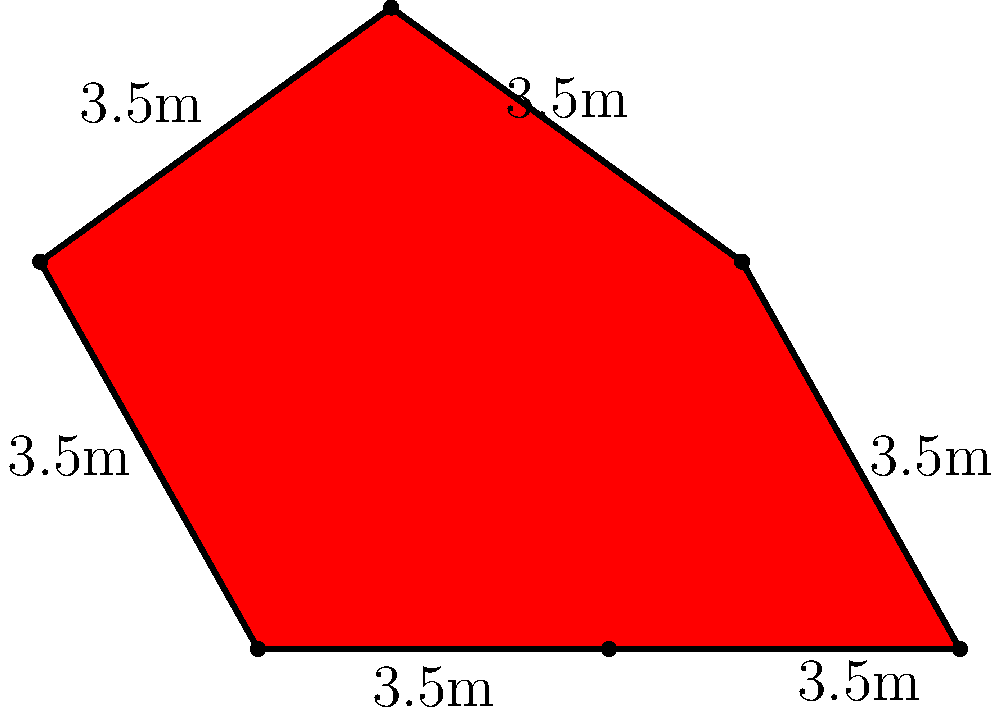For the upcoming premiere of a highly anticipated Romanian film, you've been tasked with reporting on the unique star-shaped red carpet. The carpet has 6 equal sides, each measuring 3.5 meters. What is the perimeter of this eye-catching red carpet that will be graced by local celebrities? To find the perimeter of the star-shaped red carpet, we need to follow these steps:

1. Identify the shape: The carpet is a 6-pointed star with equal sides.

2. Understand the given information:
   - Each side of the star measures 3.5 meters.
   - There are 6 sides in total.

3. Calculate the perimeter:
   - The perimeter is the sum of all sides.
   - Since all sides are equal, we can multiply the length of one side by the number of sides.
   - Perimeter = $6 \times 3.5$ meters

4. Perform the calculation:
   $6 \times 3.5 = 21$ meters

Therefore, the perimeter of the star-shaped red carpet is 21 meters.
Answer: 21 meters 